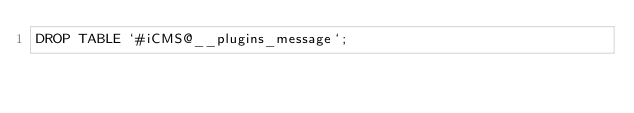Convert code to text. <code><loc_0><loc_0><loc_500><loc_500><_SQL_>DROP TABLE `#iCMS@__plugins_message`;</code> 